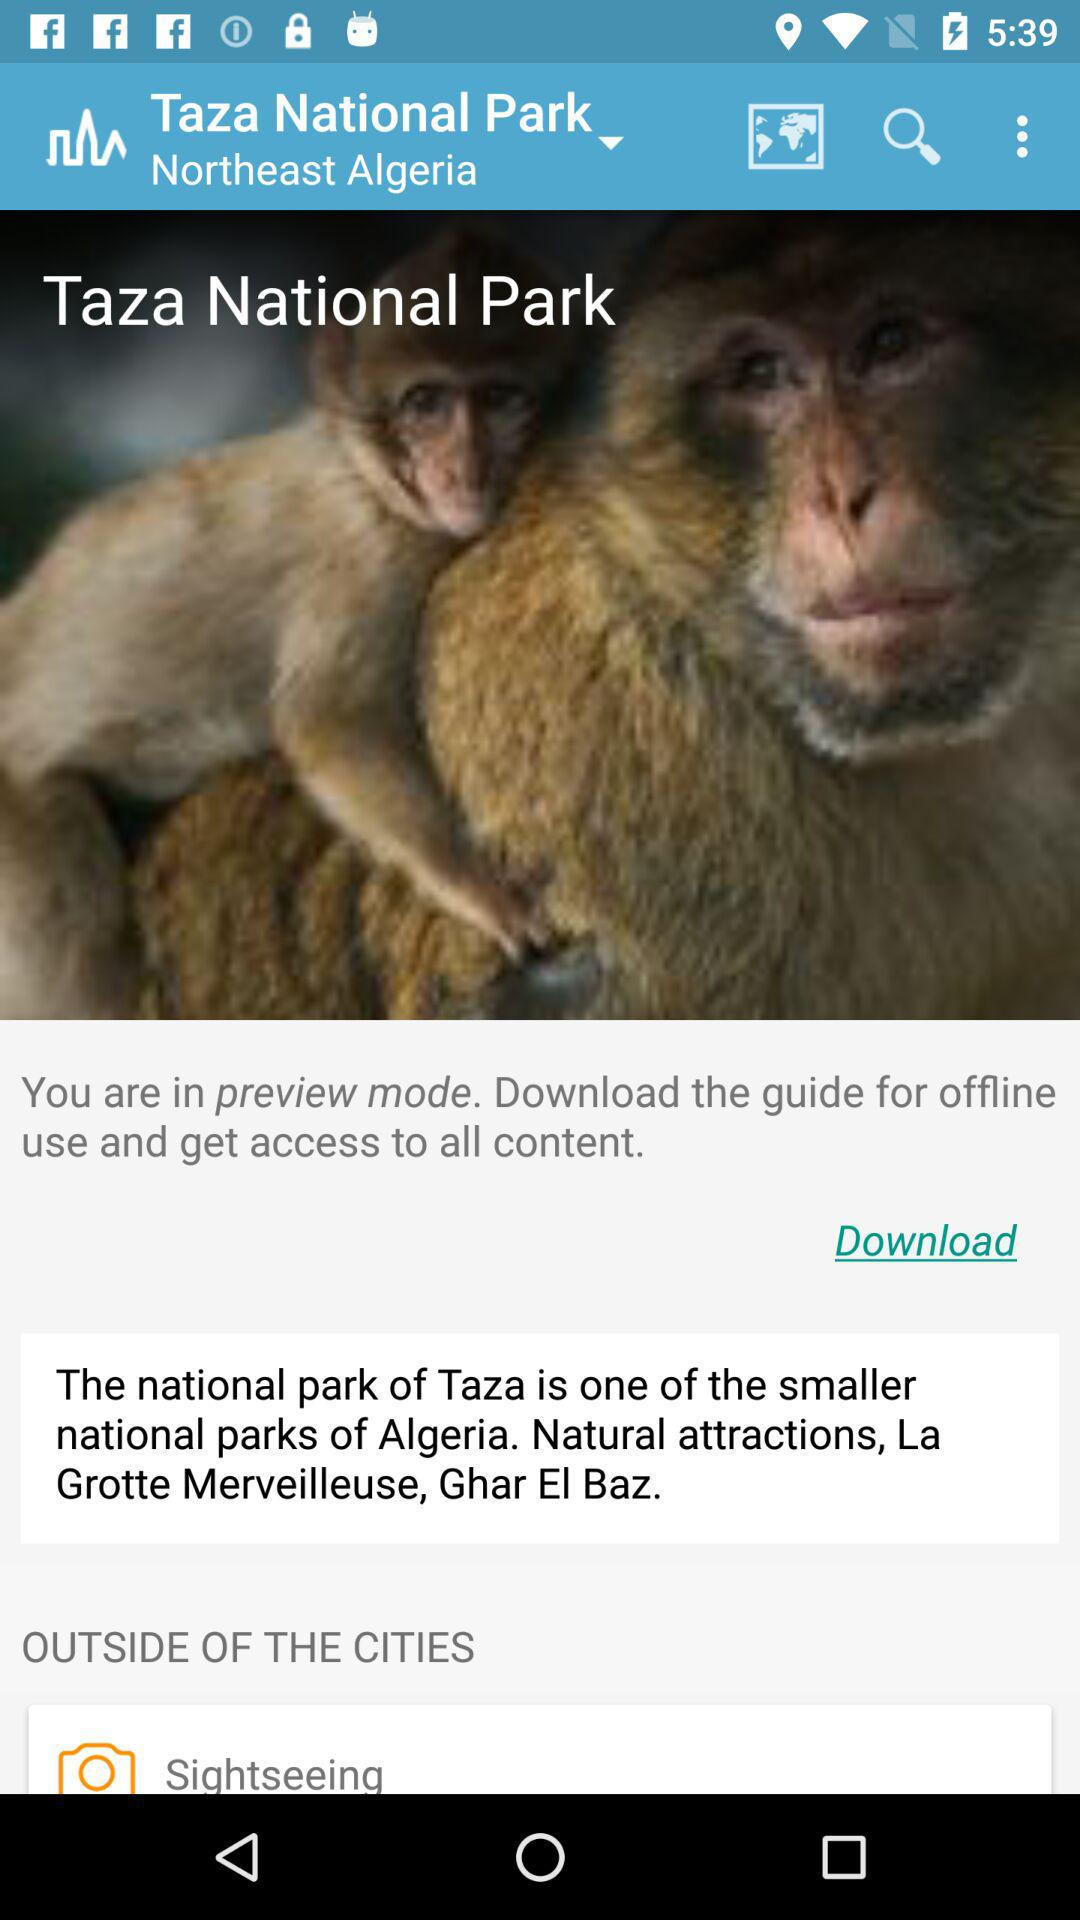Where is Taza National Park located? It is located in Northeast Algeria. 